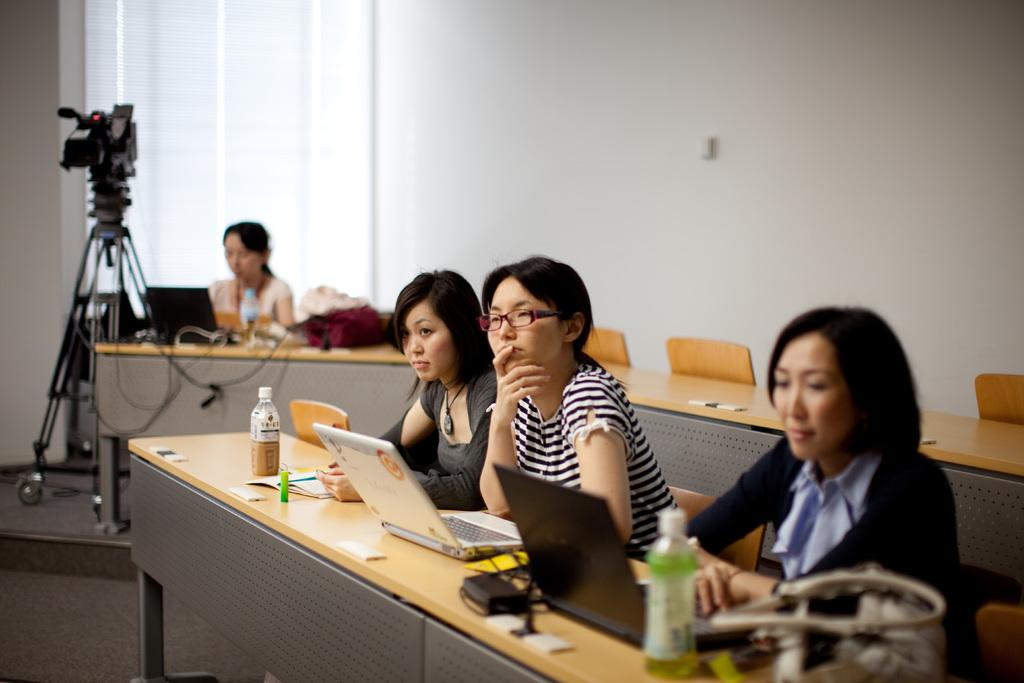What are the people in the image doing? The people in the image are sitting on chairs. What can be seen on the table in the image? There are laptops and bottles on the table. What else is present on the table? There are other objects on the table. What type of furniture is in the image? There are chairs in the image. What device is used to capture the image? There is a camera in the image. What is the background of the image? There is a wall in the image. What type of corn is being served on the table in the image? There is no corn present in the image. Are there any beds visible in the image? There are no beds present in the image. 